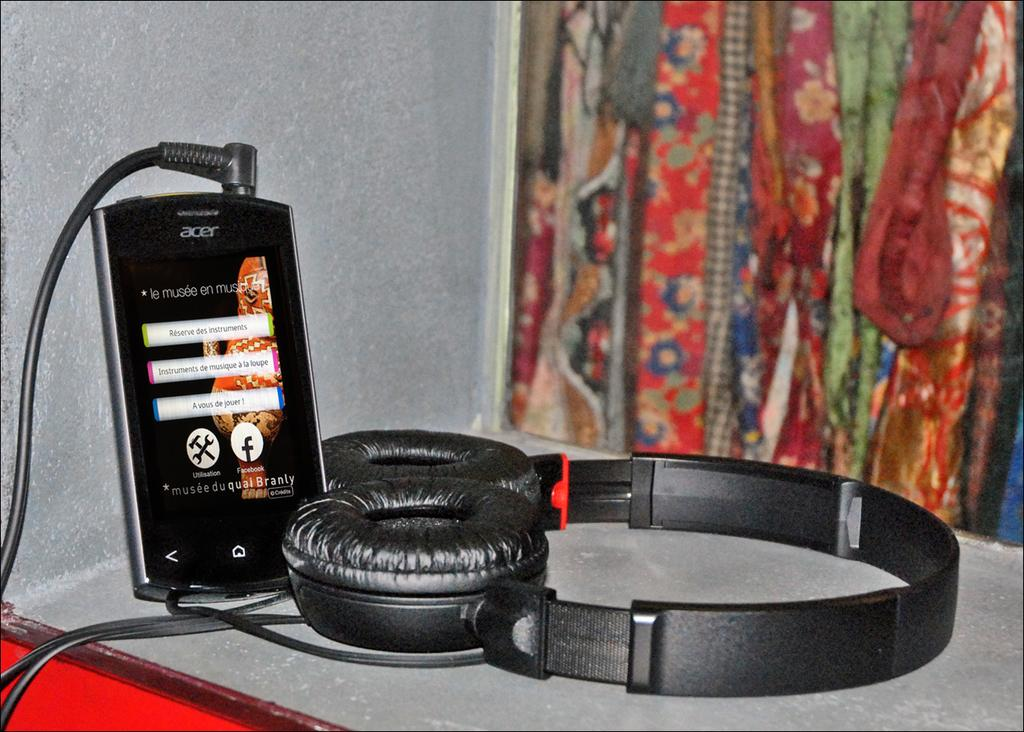<image>
Create a compact narrative representing the image presented. An Acer smartphone is charged near a black headphone. 